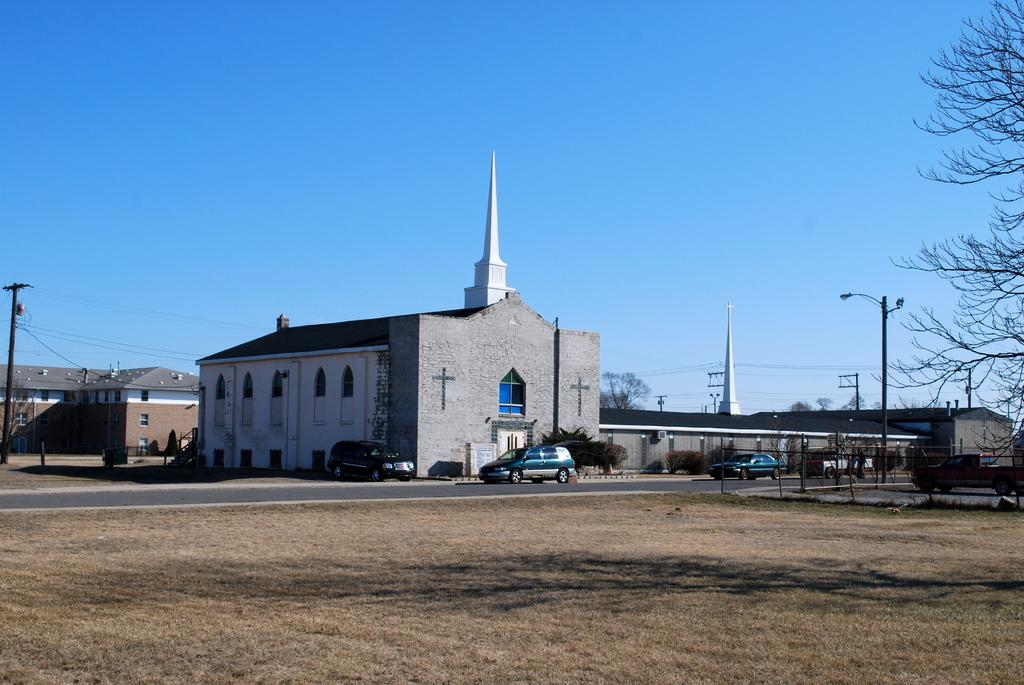What type of structures can be seen in the image? There are many buildings in the image. What mode of transportation can be seen on the road in the image? There are cars on the road in the image. What type of vegetation is visible at ground level in the image? There are trees visible at the ground level in the image. What color is the woman's sweater in the image? There is no woman or sweater present in the image. 